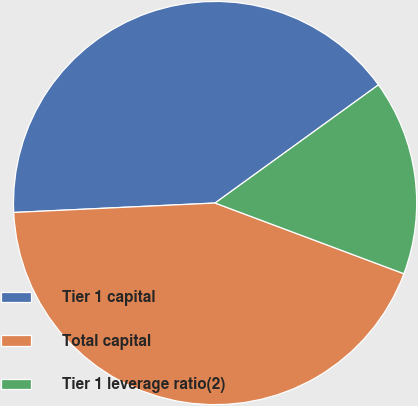<chart> <loc_0><loc_0><loc_500><loc_500><pie_chart><fcel>Tier 1 capital<fcel>Total capital<fcel>Tier 1 leverage ratio(2)<nl><fcel>40.78%<fcel>43.55%<fcel>15.67%<nl></chart> 